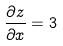Convert formula to latex. <formula><loc_0><loc_0><loc_500><loc_500>\frac { \partial z } { \partial x } = 3</formula> 